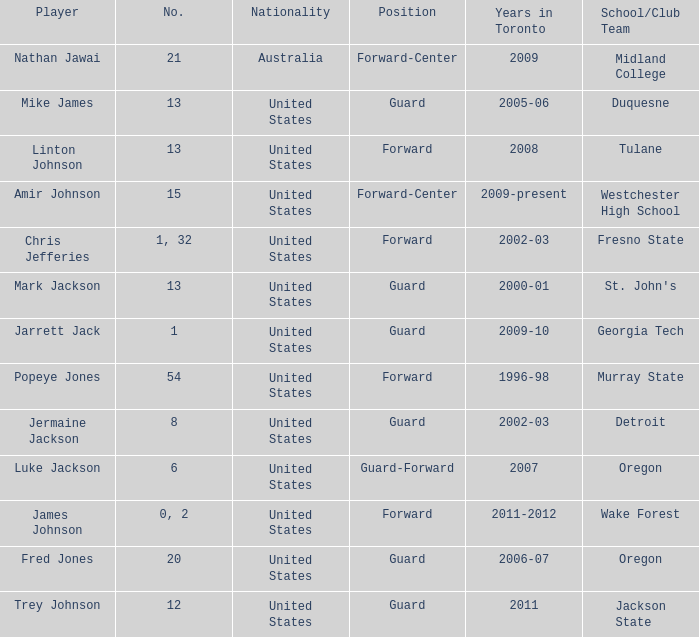What are the total amount of numbers on the Toronto team in 2005-06? 1.0. 